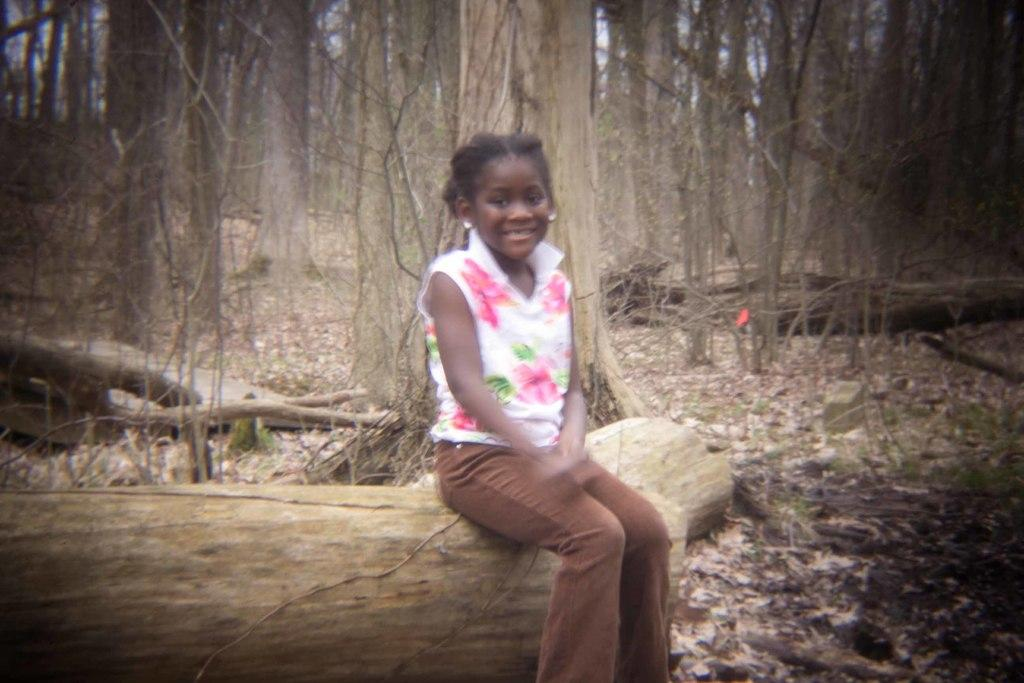Who is the main subject in the foreground of the image? There is a girl in the foreground of the image. What is the girl sitting on? The girl is sitting on a trunk. How is the trunk positioned in the image? The trunk is laid down on the ground. What can be seen in the background of the image? There are trees in the background of the image. What type of calculator is the girl using in the image? There is no calculator present in the image; the girl is sitting on a trunk with trees in the background. 